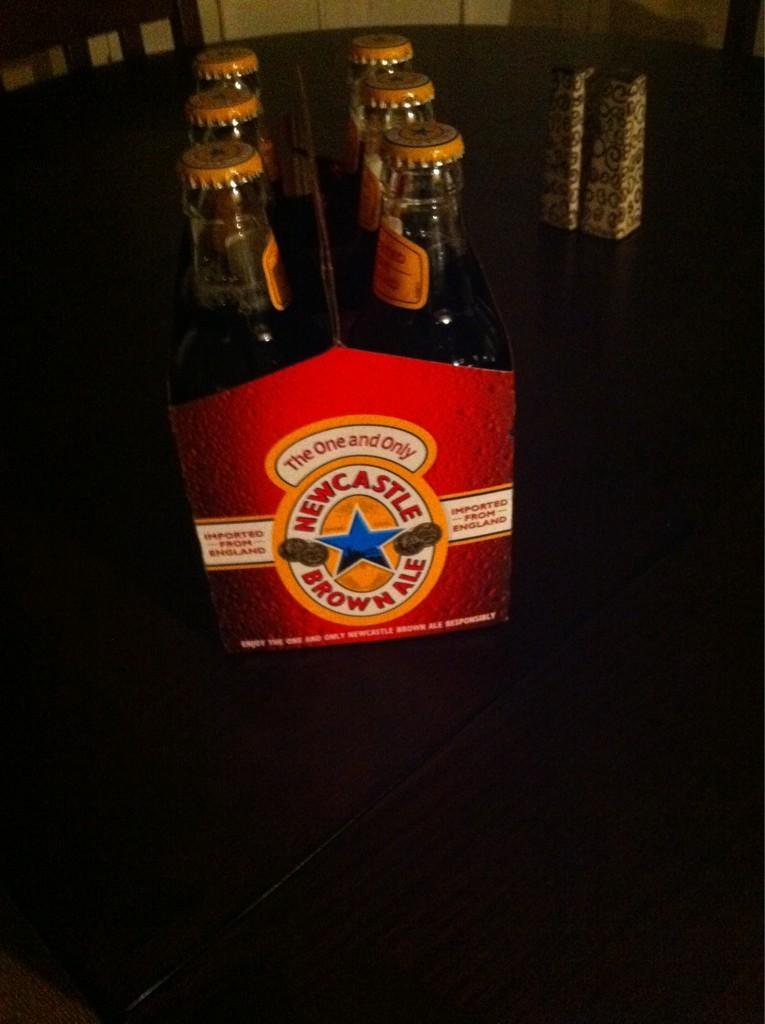What is the brand of the brown ale?
Your answer should be compact. Newcastle. What type of ale?
Give a very brief answer. Brown. 